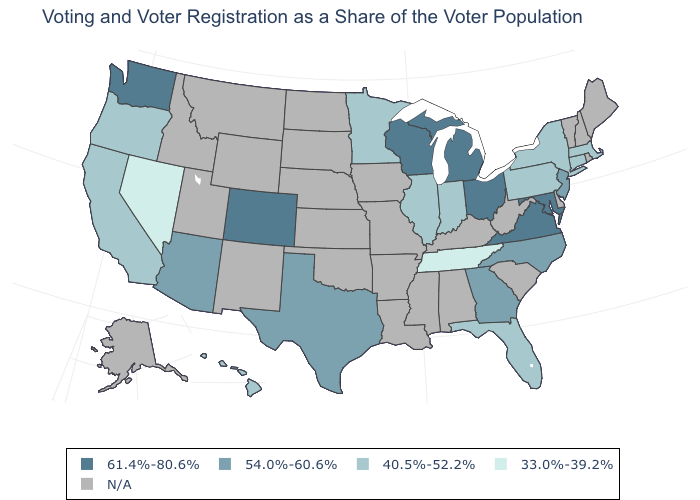What is the value of Montana?
Write a very short answer. N/A. Name the states that have a value in the range 40.5%-52.2%?
Quick response, please. California, Connecticut, Florida, Hawaii, Illinois, Indiana, Massachusetts, Minnesota, New York, Oregon, Pennsylvania. Name the states that have a value in the range 54.0%-60.6%?
Concise answer only. Arizona, Georgia, New Jersey, North Carolina, Texas. What is the lowest value in the USA?
Short answer required. 33.0%-39.2%. What is the value of Utah?
Concise answer only. N/A. Among the states that border Georgia , does Tennessee have the lowest value?
Be succinct. Yes. Does the map have missing data?
Concise answer only. Yes. What is the highest value in the South ?
Keep it brief. 61.4%-80.6%. Name the states that have a value in the range 33.0%-39.2%?
Keep it brief. Nevada, Tennessee. What is the lowest value in the MidWest?
Be succinct. 40.5%-52.2%. Does Georgia have the highest value in the South?
Write a very short answer. No. Does the first symbol in the legend represent the smallest category?
Quick response, please. No. Among the states that border New York , does Massachusetts have the highest value?
Answer briefly. No. Among the states that border Alabama , does Georgia have the highest value?
Short answer required. Yes. 